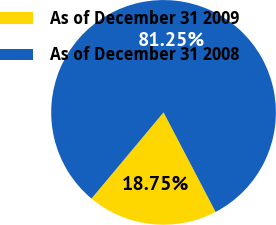<chart> <loc_0><loc_0><loc_500><loc_500><pie_chart><fcel>As of December 31 2009<fcel>As of December 31 2008<nl><fcel>18.75%<fcel>81.25%<nl></chart> 